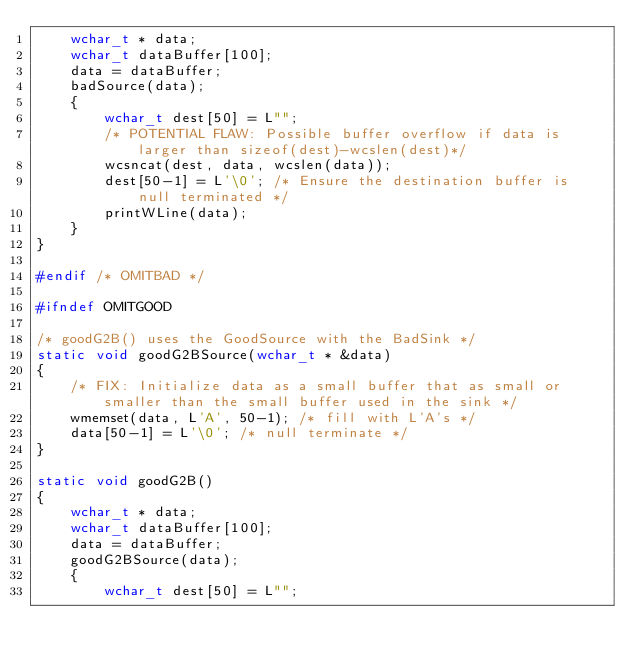Convert code to text. <code><loc_0><loc_0><loc_500><loc_500><_C++_>    wchar_t * data;
    wchar_t dataBuffer[100];
    data = dataBuffer;
    badSource(data);
    {
        wchar_t dest[50] = L"";
        /* POTENTIAL FLAW: Possible buffer overflow if data is larger than sizeof(dest)-wcslen(dest)*/
        wcsncat(dest, data, wcslen(data));
        dest[50-1] = L'\0'; /* Ensure the destination buffer is null terminated */
        printWLine(data);
    }
}

#endif /* OMITBAD */

#ifndef OMITGOOD

/* goodG2B() uses the GoodSource with the BadSink */
static void goodG2BSource(wchar_t * &data)
{
    /* FIX: Initialize data as a small buffer that as small or smaller than the small buffer used in the sink */
    wmemset(data, L'A', 50-1); /* fill with L'A's */
    data[50-1] = L'\0'; /* null terminate */
}

static void goodG2B()
{
    wchar_t * data;
    wchar_t dataBuffer[100];
    data = dataBuffer;
    goodG2BSource(data);
    {
        wchar_t dest[50] = L"";</code> 